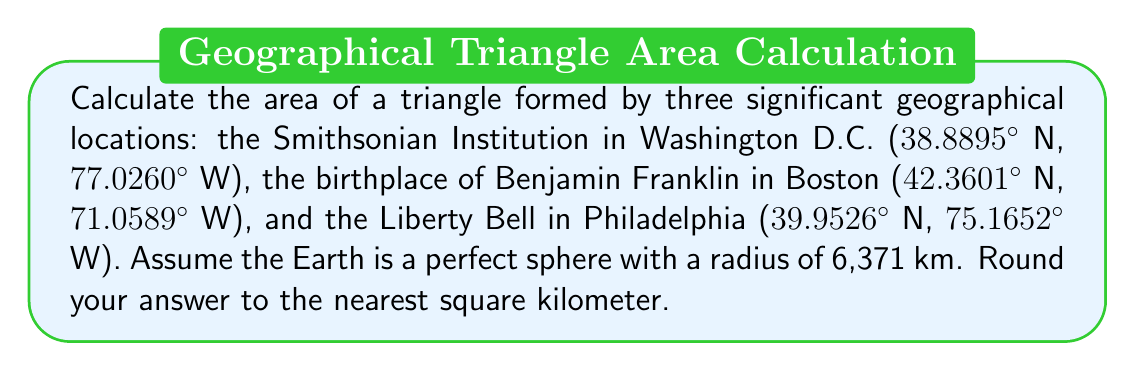Help me with this question. To solve this problem, we'll use the following steps:

1) Convert the latitude and longitude coordinates to radians.
2) Calculate the great circle distances between the points using the haversine formula.
3) Use Heron's formula to calculate the area of the spherical triangle.

Step 1: Convert coordinates to radians
Let's denote Washington D.C. as A, Boston as B, and Philadelphia as C.

$$A: (0.6785, -1.3441)$$
$$B: (0.7392, -1.2407)$$
$$C: (0.6972, -1.3119)$$

Step 2: Calculate great circle distances
We'll use the haversine formula:
$$a = \sin^2(\frac{\Delta\phi}{2}) + \cos\phi_1 \cos\phi_2 \sin^2(\frac{\Delta\lambda}{2})$$
$$c = 2 \atan2(\sqrt{a}, \sqrt{1-a})$$
$$d = Rc$$

Where $R$ is the Earth's radius, $\phi$ is latitude, and $\lambda$ is longitude.

$$AB = 6371 \cdot 2 \atan2(\sqrt{0.0009}, \sqrt{1-0.0009}) = 555.8 \text{ km}$$
$$BC = 6371 \cdot 2 \atan2(\sqrt{0.0002}, \sqrt{1-0.0002}) = 338.5 \text{ km}$$
$$CA = 6371 \cdot 2 \atan2(\sqrt{0.00003}, \sqrt{1-0.00003}) = 199.3 \text{ km}$$

Step 3: Use Heron's formula
First, calculate the semi-perimeter:
$$s = \frac{AB + BC + CA}{2} = 546.8 \text{ km}$$

Then, use Heron's formula for spherical triangles:
$$\tan(\frac{E}{4R^2}) = \sqrt{\tan(\frac{s}{2R})\tan(\frac{s-a}{2R})\tan(\frac{s-b}{2R})\tan(\frac{s-c}{2R})}$$

Where $E$ is the area of the spherical triangle and $R$ is the Earth's radius.

Plugging in the values:
$$\tan(\frac{E}{4 \cdot 6371^2}) = \sqrt{\tan(0.0429)\tan(0.0001)\tan(0.0164)\tan(0.0273)}$$

Solving for $E$:
$$E = 4 \cdot 6371^2 \cdot \atan(\sqrt{\tan(0.0429)\tan(0.0001)\tan(0.0164)\tan(0.0273)})$$
$$E = 40,616 \text{ km}^2$$
Answer: The area of the triangle formed by the Smithsonian Institution, Benjamin Franklin's birthplace, and the Liberty Bell is approximately 40,616 km². 